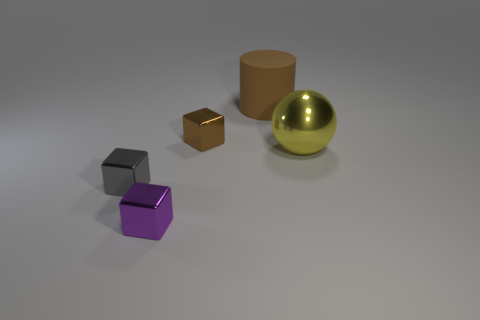Add 2 purple metal objects. How many objects exist? 7 Subtract all gray cubes. How many cubes are left? 2 Subtract 1 cylinders. How many cylinders are left? 0 Add 4 purple things. How many purple things exist? 5 Subtract 0 purple spheres. How many objects are left? 5 Subtract all balls. How many objects are left? 4 Subtract all gray cylinders. Subtract all green balls. How many cylinders are left? 1 Subtract all green spheres. How many purple blocks are left? 1 Subtract all tiny purple shiny blocks. Subtract all small metallic things. How many objects are left? 1 Add 2 brown rubber cylinders. How many brown rubber cylinders are left? 3 